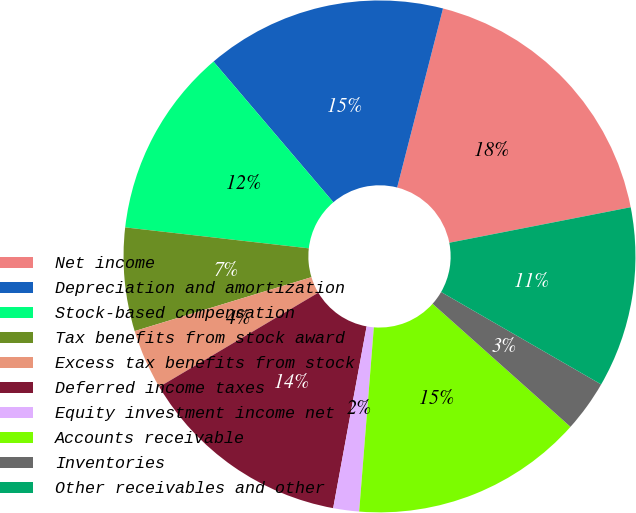Convert chart to OTSL. <chart><loc_0><loc_0><loc_500><loc_500><pie_chart><fcel>Net income<fcel>Depreciation and amortization<fcel>Stock-based compensation<fcel>Tax benefits from stock award<fcel>Excess tax benefits from stock<fcel>Deferred income taxes<fcel>Equity investment income net<fcel>Accounts receivable<fcel>Inventories<fcel>Other receivables and other<nl><fcel>17.93%<fcel>15.22%<fcel>11.96%<fcel>6.52%<fcel>3.8%<fcel>13.59%<fcel>1.63%<fcel>14.67%<fcel>3.26%<fcel>11.41%<nl></chart> 